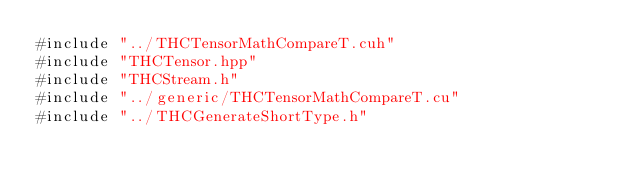Convert code to text. <code><loc_0><loc_0><loc_500><loc_500><_Cuda_>#include "../THCTensorMathCompareT.cuh"
#include "THCTensor.hpp"
#include "THCStream.h"
#include "../generic/THCTensorMathCompareT.cu"
#include "../THCGenerateShortType.h"
</code> 